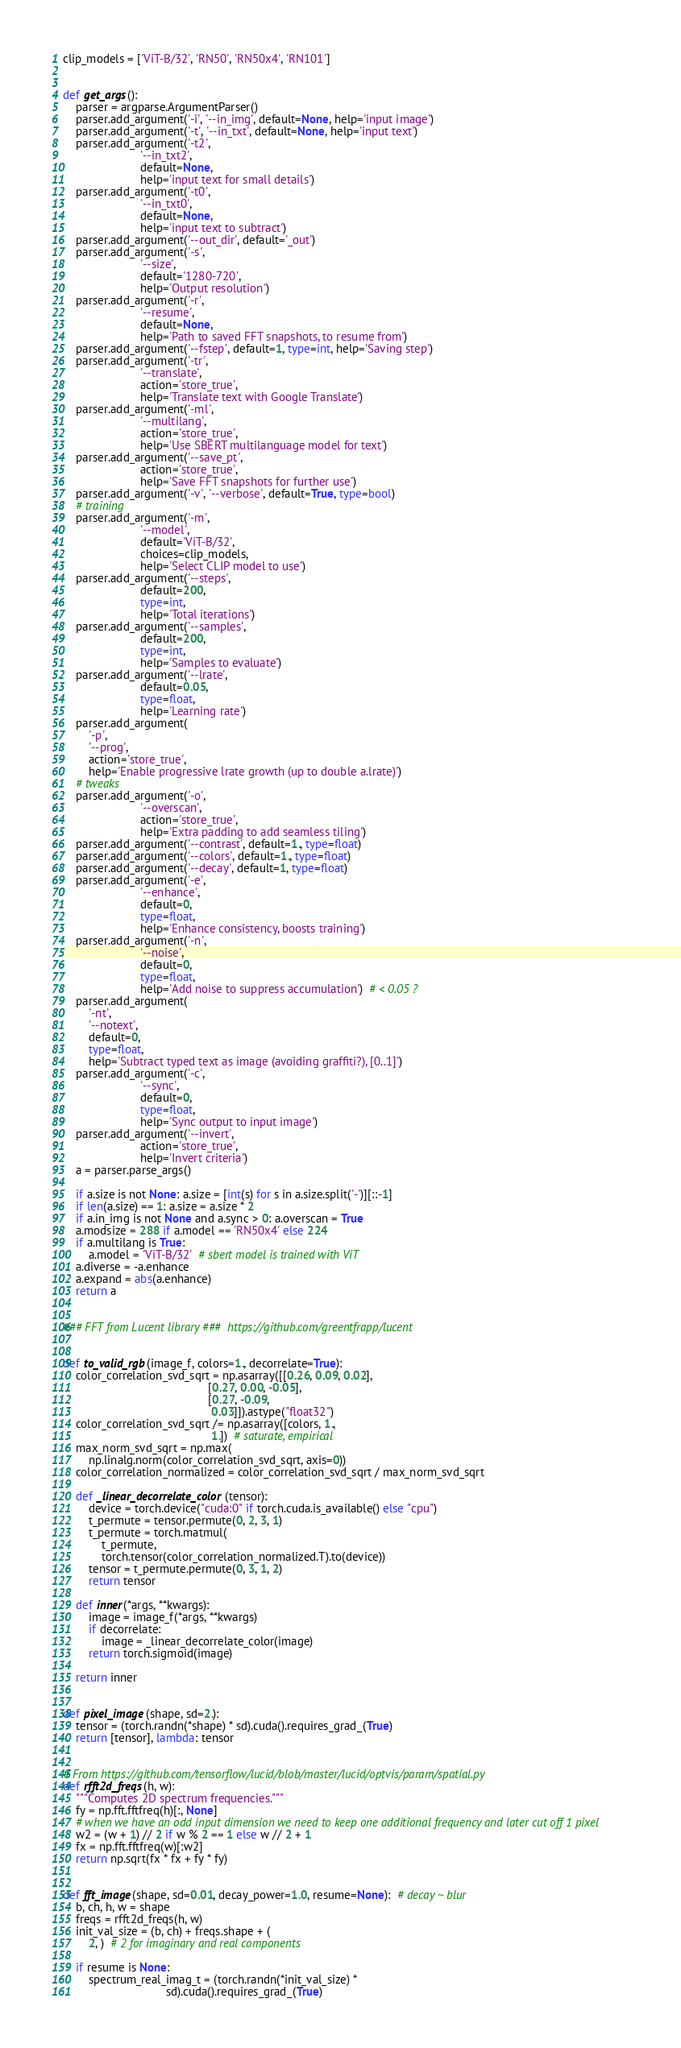Convert code to text. <code><loc_0><loc_0><loc_500><loc_500><_Python_>clip_models = ['ViT-B/32', 'RN50', 'RN50x4', 'RN101']


def get_args():
    parser = argparse.ArgumentParser()
    parser.add_argument('-i', '--in_img', default=None, help='input image')
    parser.add_argument('-t', '--in_txt', default=None, help='input text')
    parser.add_argument('-t2',
                        '--in_txt2',
                        default=None,
                        help='input text for small details')
    parser.add_argument('-t0',
                        '--in_txt0',
                        default=None,
                        help='input text to subtract')
    parser.add_argument('--out_dir', default='_out')
    parser.add_argument('-s',
                        '--size',
                        default='1280-720',
                        help='Output resolution')
    parser.add_argument('-r',
                        '--resume',
                        default=None,
                        help='Path to saved FFT snapshots, to resume from')
    parser.add_argument('--fstep', default=1, type=int, help='Saving step')
    parser.add_argument('-tr',
                        '--translate',
                        action='store_true',
                        help='Translate text with Google Translate')
    parser.add_argument('-ml',
                        '--multilang',
                        action='store_true',
                        help='Use SBERT multilanguage model for text')
    parser.add_argument('--save_pt',
                        action='store_true',
                        help='Save FFT snapshots for further use')
    parser.add_argument('-v', '--verbose', default=True, type=bool)
    # training
    parser.add_argument('-m',
                        '--model',
                        default='ViT-B/32',
                        choices=clip_models,
                        help='Select CLIP model to use')
    parser.add_argument('--steps',
                        default=200,
                        type=int,
                        help='Total iterations')
    parser.add_argument('--samples',
                        default=200,
                        type=int,
                        help='Samples to evaluate')
    parser.add_argument('--lrate',
                        default=0.05,
                        type=float,
                        help='Learning rate')
    parser.add_argument(
        '-p',
        '--prog',
        action='store_true',
        help='Enable progressive lrate growth (up to double a.lrate)')
    # tweaks
    parser.add_argument('-o',
                        '--overscan',
                        action='store_true',
                        help='Extra padding to add seamless tiling')
    parser.add_argument('--contrast', default=1., type=float)
    parser.add_argument('--colors', default=1., type=float)
    parser.add_argument('--decay', default=1, type=float)
    parser.add_argument('-e',
                        '--enhance',
                        default=0,
                        type=float,
                        help='Enhance consistency, boosts training')
    parser.add_argument('-n',
                        '--noise',
                        default=0,
                        type=float,
                        help='Add noise to suppress accumulation')  # < 0.05 ?
    parser.add_argument(
        '-nt',
        '--notext',
        default=0,
        type=float,
        help='Subtract typed text as image (avoiding graffiti?), [0..1]')
    parser.add_argument('-c',
                        '--sync',
                        default=0,
                        type=float,
                        help='Sync output to input image')
    parser.add_argument('--invert',
                        action='store_true',
                        help='Invert criteria')
    a = parser.parse_args()

    if a.size is not None: a.size = [int(s) for s in a.size.split('-')][::-1]
    if len(a.size) == 1: a.size = a.size * 2
    if a.in_img is not None and a.sync > 0: a.overscan = True
    a.modsize = 288 if a.model == 'RN50x4' else 224
    if a.multilang is True:
        a.model = 'ViT-B/32'  # sbert model is trained with ViT
    a.diverse = -a.enhance
    a.expand = abs(a.enhance)
    return a


### FFT from Lucent library ###  https://github.com/greentfrapp/lucent


def to_valid_rgb(image_f, colors=1., decorrelate=True):
    color_correlation_svd_sqrt = np.asarray([[0.26, 0.09, 0.02],
                                             [0.27, 0.00, -0.05],
                                             [0.27, -0.09,
                                              0.03]]).astype("float32")
    color_correlation_svd_sqrt /= np.asarray([colors, 1.,
                                              1.])  # saturate, empirical
    max_norm_svd_sqrt = np.max(
        np.linalg.norm(color_correlation_svd_sqrt, axis=0))
    color_correlation_normalized = color_correlation_svd_sqrt / max_norm_svd_sqrt

    def _linear_decorrelate_color(tensor):
        device = torch.device("cuda:0" if torch.cuda.is_available() else "cpu")
        t_permute = tensor.permute(0, 2, 3, 1)
        t_permute = torch.matmul(
            t_permute,
            torch.tensor(color_correlation_normalized.T).to(device))
        tensor = t_permute.permute(0, 3, 1, 2)
        return tensor

    def inner(*args, **kwargs):
        image = image_f(*args, **kwargs)
        if decorrelate:
            image = _linear_decorrelate_color(image)
        return torch.sigmoid(image)

    return inner


def pixel_image(shape, sd=2.):
    tensor = (torch.randn(*shape) * sd).cuda().requires_grad_(True)
    return [tensor], lambda: tensor


# From https://github.com/tensorflow/lucid/blob/master/lucid/optvis/param/spatial.py
def rfft2d_freqs(h, w):
    """Computes 2D spectrum frequencies."""
    fy = np.fft.fftfreq(h)[:, None]
    # when we have an odd input dimension we need to keep one additional frequency and later cut off 1 pixel
    w2 = (w + 1) // 2 if w % 2 == 1 else w // 2 + 1
    fx = np.fft.fftfreq(w)[:w2]
    return np.sqrt(fx * fx + fy * fy)


def fft_image(shape, sd=0.01, decay_power=1.0, resume=None):  # decay ~ blur
    b, ch, h, w = shape
    freqs = rfft2d_freqs(h, w)
    init_val_size = (b, ch) + freqs.shape + (
        2, )  # 2 for imaginary and real components

    if resume is None:
        spectrum_real_imag_t = (torch.randn(*init_val_size) *
                                sd).cuda().requires_grad_(True)</code> 